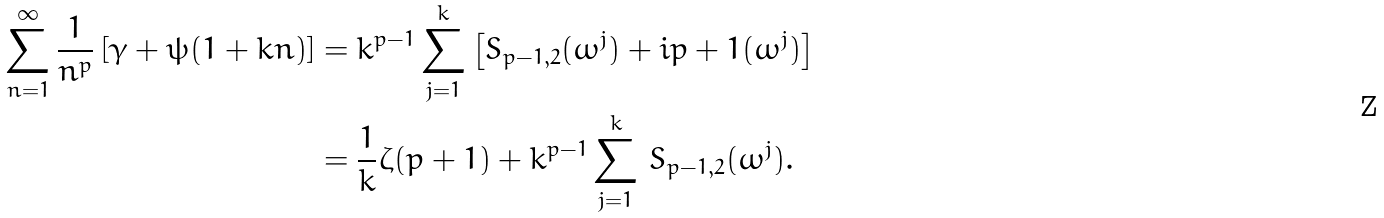Convert formula to latex. <formula><loc_0><loc_0><loc_500><loc_500>\sum _ { n = 1 } ^ { \infty } \frac { 1 } { n ^ { p } } \left [ \gamma + \psi ( 1 + k n ) \right ] & = k ^ { p - 1 } \sum _ { j = 1 } ^ { k } \left [ S _ { p - 1 , 2 } ( \omega ^ { j } ) + \L i { p + 1 } ( \omega ^ { j } ) \right ] \\ & = \frac { 1 } { k } \zeta ( p + 1 ) + k ^ { p - 1 } \sum _ { j = 1 } ^ { k } \, S _ { p - 1 , 2 } ( \omega ^ { j } ) .</formula> 